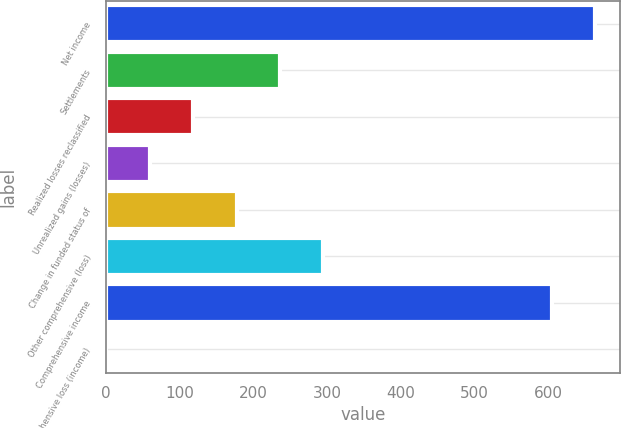<chart> <loc_0><loc_0><loc_500><loc_500><bar_chart><fcel>Net income<fcel>Settlements<fcel>Realized losses reclassified<fcel>Unrealized gains (losses)<fcel>Change in funded status of<fcel>Other comprehensive (loss)<fcel>Comprehensive income<fcel>Comprehensive loss (income)<nl><fcel>663.22<fcel>235.74<fcel>118.02<fcel>59.16<fcel>176.88<fcel>294.6<fcel>604.36<fcel>0.3<nl></chart> 